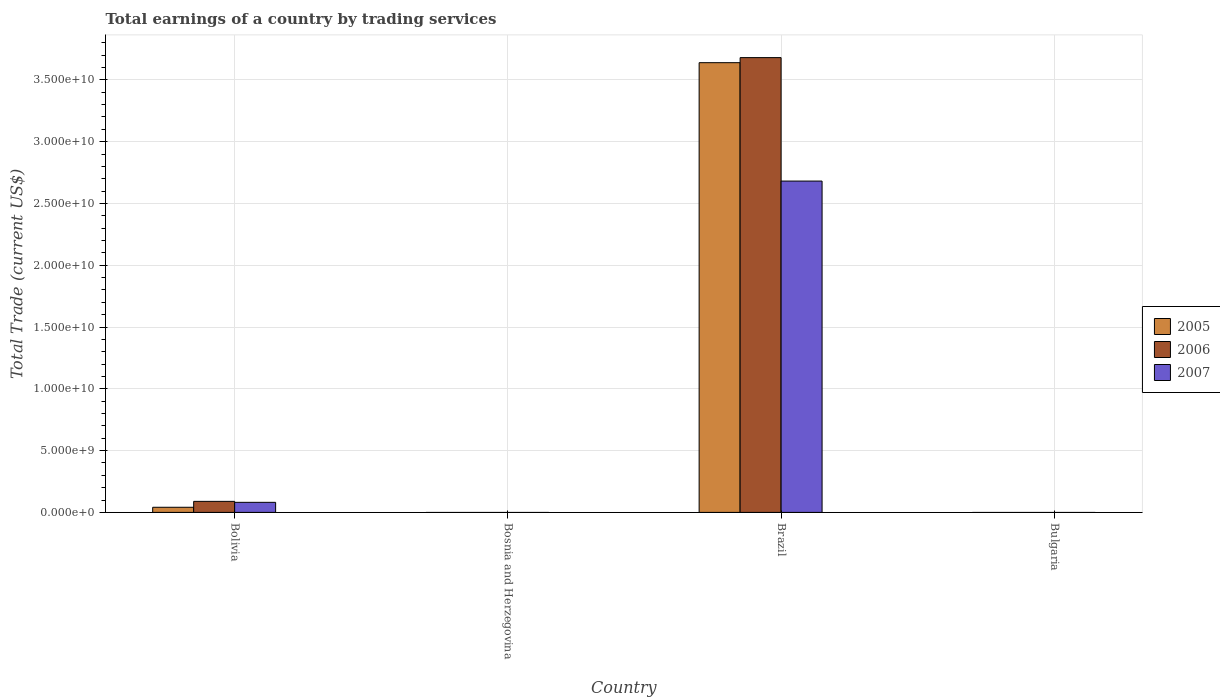Are the number of bars on each tick of the X-axis equal?
Ensure brevity in your answer.  No. Across all countries, what is the maximum total earnings in 2007?
Make the answer very short. 2.68e+1. In which country was the total earnings in 2005 maximum?
Your response must be concise. Brazil. What is the total total earnings in 2006 in the graph?
Your answer should be compact. 3.77e+1. What is the difference between the total earnings in 2007 in Bolivia and that in Brazil?
Offer a terse response. -2.60e+1. What is the difference between the total earnings in 2007 in Bosnia and Herzegovina and the total earnings in 2006 in Brazil?
Provide a short and direct response. -3.68e+1. What is the average total earnings in 2006 per country?
Ensure brevity in your answer.  9.42e+09. What is the difference between the total earnings of/in 2006 and total earnings of/in 2005 in Bolivia?
Give a very brief answer. 4.78e+08. In how many countries, is the total earnings in 2005 greater than 32000000000 US$?
Keep it short and to the point. 1. Is the total earnings in 2005 in Bolivia less than that in Brazil?
Ensure brevity in your answer.  Yes. What is the difference between the highest and the lowest total earnings in 2006?
Offer a terse response. 3.68e+1. Is it the case that in every country, the sum of the total earnings in 2005 and total earnings in 2006 is greater than the total earnings in 2007?
Offer a very short reply. No. How many bars are there?
Your response must be concise. 6. Are all the bars in the graph horizontal?
Your answer should be compact. No. Does the graph contain any zero values?
Give a very brief answer. Yes. How many legend labels are there?
Ensure brevity in your answer.  3. How are the legend labels stacked?
Provide a succinct answer. Vertical. What is the title of the graph?
Your answer should be compact. Total earnings of a country by trading services. What is the label or title of the X-axis?
Your response must be concise. Country. What is the label or title of the Y-axis?
Your response must be concise. Total Trade (current US$). What is the Total Trade (current US$) in 2005 in Bolivia?
Provide a succinct answer. 4.15e+08. What is the Total Trade (current US$) in 2006 in Bolivia?
Offer a very short reply. 8.92e+08. What is the Total Trade (current US$) in 2007 in Bolivia?
Give a very brief answer. 8.15e+08. What is the Total Trade (current US$) of 2006 in Bosnia and Herzegovina?
Keep it short and to the point. 0. What is the Total Trade (current US$) of 2007 in Bosnia and Herzegovina?
Your answer should be compact. 0. What is the Total Trade (current US$) of 2005 in Brazil?
Provide a short and direct response. 3.64e+1. What is the Total Trade (current US$) in 2006 in Brazil?
Keep it short and to the point. 3.68e+1. What is the Total Trade (current US$) in 2007 in Brazil?
Offer a terse response. 2.68e+1. What is the Total Trade (current US$) of 2005 in Bulgaria?
Provide a succinct answer. 0. What is the Total Trade (current US$) of 2006 in Bulgaria?
Your answer should be compact. 0. What is the Total Trade (current US$) of 2007 in Bulgaria?
Your response must be concise. 0. Across all countries, what is the maximum Total Trade (current US$) in 2005?
Provide a short and direct response. 3.64e+1. Across all countries, what is the maximum Total Trade (current US$) in 2006?
Provide a succinct answer. 3.68e+1. Across all countries, what is the maximum Total Trade (current US$) in 2007?
Ensure brevity in your answer.  2.68e+1. Across all countries, what is the minimum Total Trade (current US$) in 2007?
Your response must be concise. 0. What is the total Total Trade (current US$) in 2005 in the graph?
Your answer should be compact. 3.68e+1. What is the total Total Trade (current US$) of 2006 in the graph?
Your answer should be very brief. 3.77e+1. What is the total Total Trade (current US$) in 2007 in the graph?
Keep it short and to the point. 2.76e+1. What is the difference between the Total Trade (current US$) of 2005 in Bolivia and that in Brazil?
Keep it short and to the point. -3.60e+1. What is the difference between the Total Trade (current US$) of 2006 in Bolivia and that in Brazil?
Give a very brief answer. -3.59e+1. What is the difference between the Total Trade (current US$) in 2007 in Bolivia and that in Brazil?
Ensure brevity in your answer.  -2.60e+1. What is the difference between the Total Trade (current US$) in 2005 in Bolivia and the Total Trade (current US$) in 2006 in Brazil?
Ensure brevity in your answer.  -3.64e+1. What is the difference between the Total Trade (current US$) in 2005 in Bolivia and the Total Trade (current US$) in 2007 in Brazil?
Offer a very short reply. -2.64e+1. What is the difference between the Total Trade (current US$) of 2006 in Bolivia and the Total Trade (current US$) of 2007 in Brazil?
Give a very brief answer. -2.59e+1. What is the average Total Trade (current US$) in 2005 per country?
Offer a very short reply. 9.20e+09. What is the average Total Trade (current US$) in 2006 per country?
Make the answer very short. 9.42e+09. What is the average Total Trade (current US$) of 2007 per country?
Your response must be concise. 6.91e+09. What is the difference between the Total Trade (current US$) in 2005 and Total Trade (current US$) in 2006 in Bolivia?
Your response must be concise. -4.78e+08. What is the difference between the Total Trade (current US$) of 2005 and Total Trade (current US$) of 2007 in Bolivia?
Your response must be concise. -4.00e+08. What is the difference between the Total Trade (current US$) of 2006 and Total Trade (current US$) of 2007 in Bolivia?
Make the answer very short. 7.79e+07. What is the difference between the Total Trade (current US$) in 2005 and Total Trade (current US$) in 2006 in Brazil?
Keep it short and to the point. -4.10e+08. What is the difference between the Total Trade (current US$) in 2005 and Total Trade (current US$) in 2007 in Brazil?
Keep it short and to the point. 9.58e+09. What is the difference between the Total Trade (current US$) in 2006 and Total Trade (current US$) in 2007 in Brazil?
Your answer should be compact. 9.99e+09. What is the ratio of the Total Trade (current US$) in 2005 in Bolivia to that in Brazil?
Provide a short and direct response. 0.01. What is the ratio of the Total Trade (current US$) of 2006 in Bolivia to that in Brazil?
Make the answer very short. 0.02. What is the ratio of the Total Trade (current US$) of 2007 in Bolivia to that in Brazil?
Make the answer very short. 0.03. What is the difference between the highest and the lowest Total Trade (current US$) in 2005?
Offer a very short reply. 3.64e+1. What is the difference between the highest and the lowest Total Trade (current US$) in 2006?
Your response must be concise. 3.68e+1. What is the difference between the highest and the lowest Total Trade (current US$) of 2007?
Your answer should be compact. 2.68e+1. 